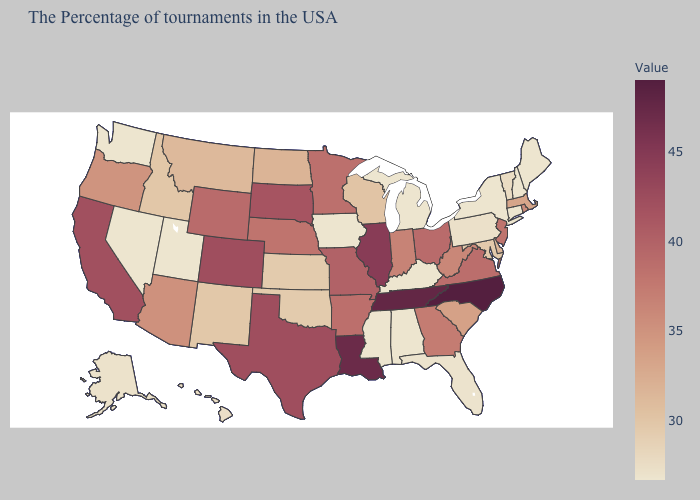Does North Carolina have the highest value in the USA?
Short answer required. Yes. Among the states that border Massachusetts , which have the lowest value?
Quick response, please. New Hampshire, Connecticut, New York. Does Wisconsin have the highest value in the MidWest?
Write a very short answer. No. Does California have a lower value than Louisiana?
Give a very brief answer. Yes. Does the map have missing data?
Be succinct. No. Which states have the highest value in the USA?
Quick response, please. North Carolina. 